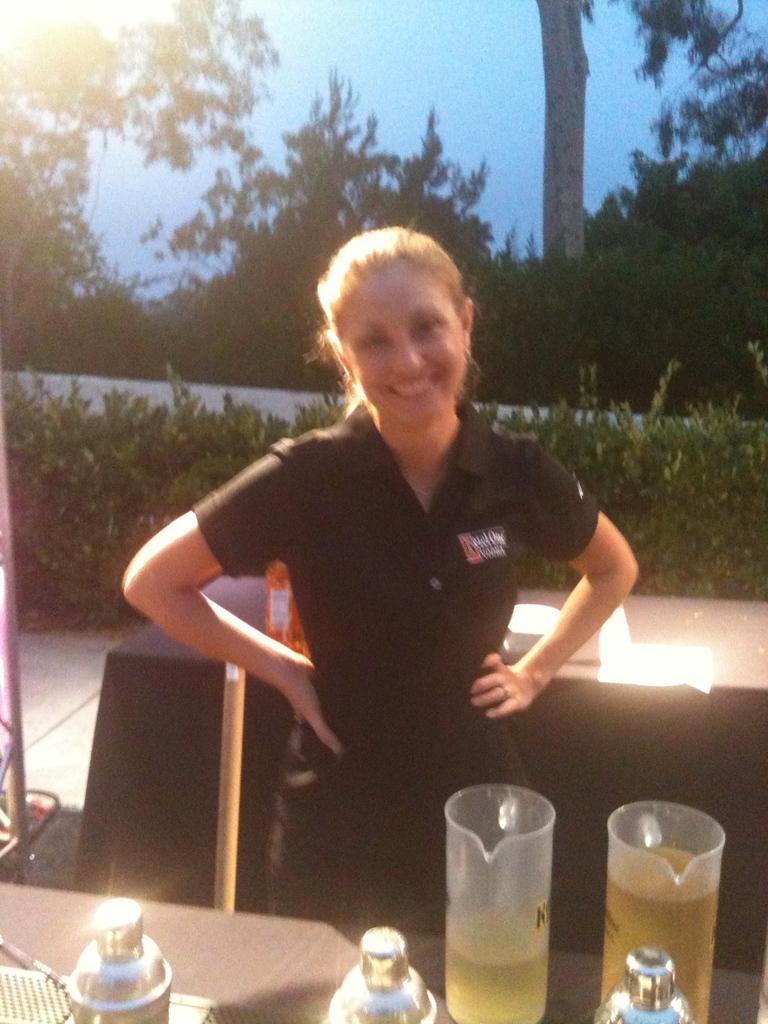Please provide a concise description of this image. This is an outside view. In the middle of the image there is a woman wearing black color dress, standing, smiling and giving pose for the picture. In front of her there is a table on which bowls, jars and some other objects are placed. At the back of her there is another table which is covered with a black color cloth. On the table there are some objects. In the background there are many plants and trees. At the top of the image I can see the sky. 